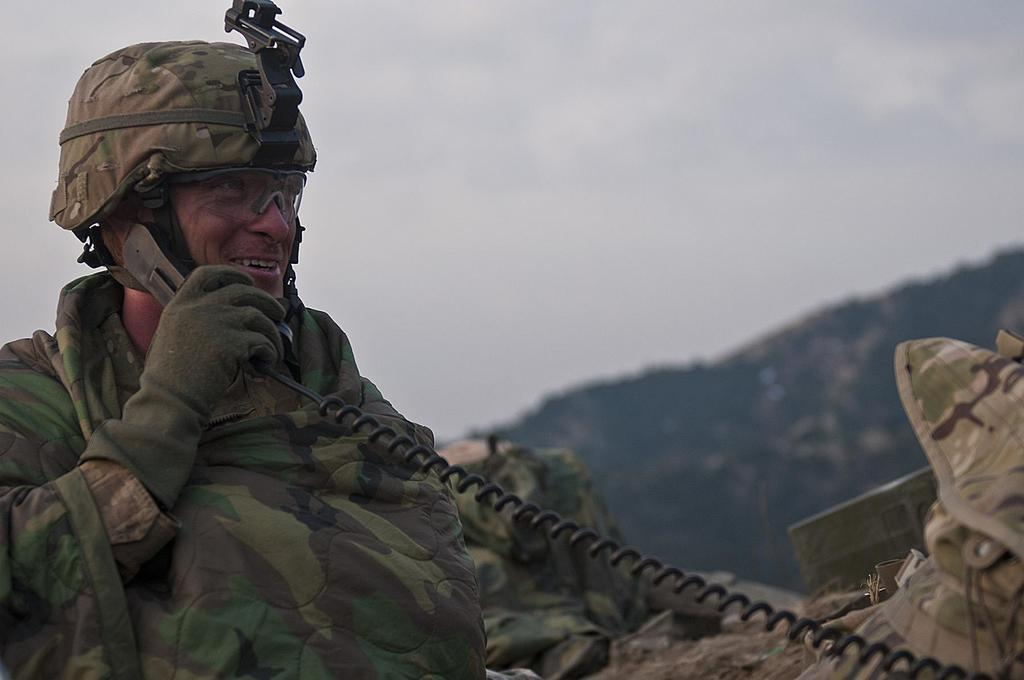What is the main subject of the picture? The main subject of the picture is a man. What is the man doing in the picture? The man is standing in the picture. What is the man holding in his right hand? The man is holding a telephone in his right hand. What can be seen in the background of the picture? There is a mountain in the background of the picture. How would you describe the sky in the picture? The sky is clear in the picture. What type of cabbage is growing on the man's toe in the image? There is no cabbage or any reference to a man's toe in the image. 